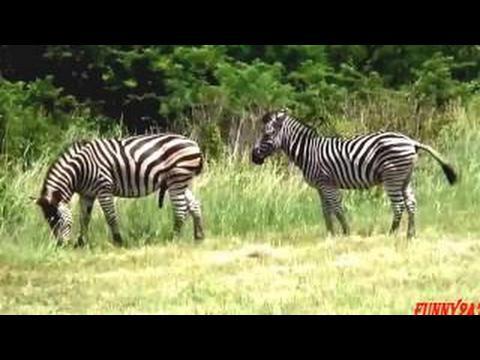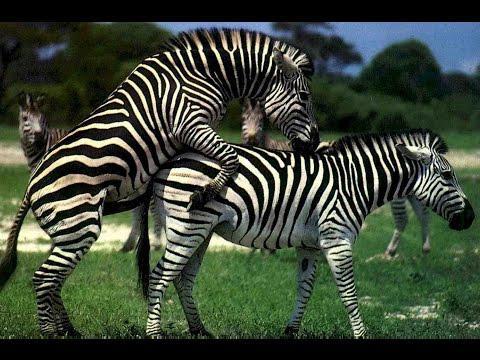The first image is the image on the left, the second image is the image on the right. Analyze the images presented: Is the assertion "The left image shows a smaller hooved animal next to a bigger hooved animal, and the right image shows one zebra with its front legs over another zebra's back." valid? Answer yes or no. No. 